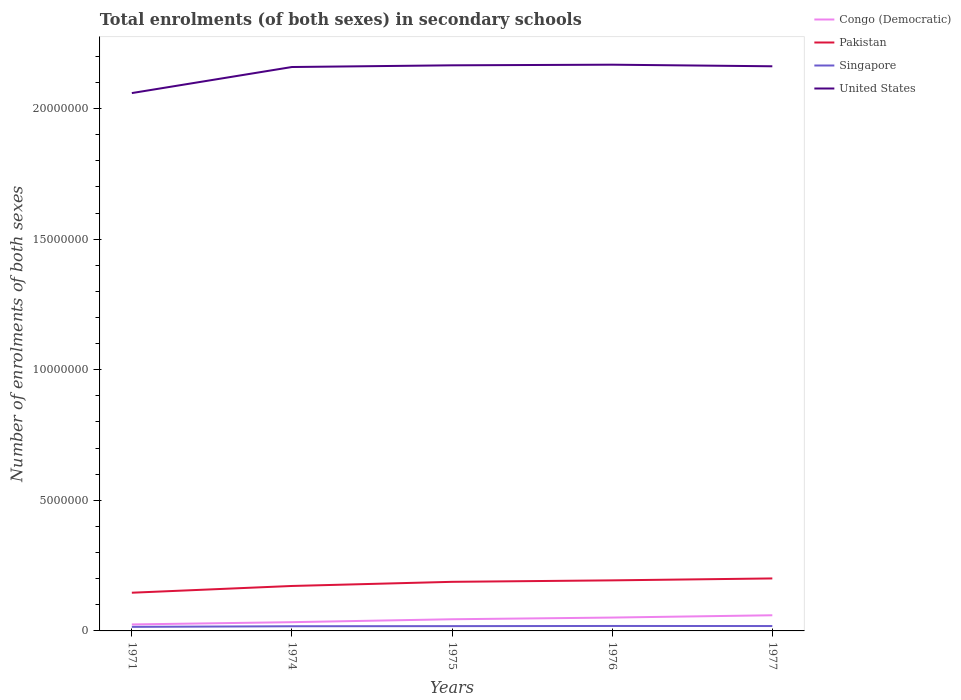Across all years, what is the maximum number of enrolments in secondary schools in Pakistan?
Keep it short and to the point. 1.46e+06. In which year was the number of enrolments in secondary schools in United States maximum?
Make the answer very short. 1971. What is the total number of enrolments in secondary schools in Congo (Democratic) in the graph?
Offer a terse response. -1.98e+05. What is the difference between the highest and the second highest number of enrolments in secondary schools in Pakistan?
Ensure brevity in your answer.  5.47e+05. Is the number of enrolments in secondary schools in Pakistan strictly greater than the number of enrolments in secondary schools in Singapore over the years?
Provide a short and direct response. No. How many lines are there?
Offer a terse response. 4. How many years are there in the graph?
Provide a succinct answer. 5. What is the difference between two consecutive major ticks on the Y-axis?
Give a very brief answer. 5.00e+06. What is the title of the graph?
Provide a short and direct response. Total enrolments (of both sexes) in secondary schools. What is the label or title of the X-axis?
Make the answer very short. Years. What is the label or title of the Y-axis?
Give a very brief answer. Number of enrolments of both sexes. What is the Number of enrolments of both sexes in Congo (Democratic) in 1971?
Provide a short and direct response. 2.48e+05. What is the Number of enrolments of both sexes of Pakistan in 1971?
Give a very brief answer. 1.46e+06. What is the Number of enrolments of both sexes in Singapore in 1971?
Keep it short and to the point. 1.56e+05. What is the Number of enrolments of both sexes in United States in 1971?
Offer a terse response. 2.06e+07. What is the Number of enrolments of both sexes in Congo (Democratic) in 1974?
Your answer should be very brief. 3.35e+05. What is the Number of enrolments of both sexes of Pakistan in 1974?
Provide a short and direct response. 1.72e+06. What is the Number of enrolments of both sexes in Singapore in 1974?
Provide a succinct answer. 1.79e+05. What is the Number of enrolments of both sexes of United States in 1974?
Your answer should be compact. 2.16e+07. What is the Number of enrolments of both sexes of Congo (Democratic) in 1975?
Offer a very short reply. 4.47e+05. What is the Number of enrolments of both sexes in Pakistan in 1975?
Give a very brief answer. 1.88e+06. What is the Number of enrolments of both sexes of Singapore in 1975?
Your answer should be very brief. 1.83e+05. What is the Number of enrolments of both sexes in United States in 1975?
Provide a succinct answer. 2.17e+07. What is the Number of enrolments of both sexes in Congo (Democratic) in 1976?
Give a very brief answer. 5.11e+05. What is the Number of enrolments of both sexes in Pakistan in 1976?
Your answer should be very brief. 1.94e+06. What is the Number of enrolments of both sexes in Singapore in 1976?
Your answer should be compact. 1.90e+05. What is the Number of enrolments of both sexes of United States in 1976?
Provide a succinct answer. 2.17e+07. What is the Number of enrolments of both sexes of Congo (Democratic) in 1977?
Provide a short and direct response. 5.99e+05. What is the Number of enrolments of both sexes in Pakistan in 1977?
Your answer should be very brief. 2.01e+06. What is the Number of enrolments of both sexes of Singapore in 1977?
Keep it short and to the point. 1.87e+05. What is the Number of enrolments of both sexes of United States in 1977?
Offer a very short reply. 2.16e+07. Across all years, what is the maximum Number of enrolments of both sexes of Congo (Democratic)?
Ensure brevity in your answer.  5.99e+05. Across all years, what is the maximum Number of enrolments of both sexes of Pakistan?
Keep it short and to the point. 2.01e+06. Across all years, what is the maximum Number of enrolments of both sexes in Singapore?
Your response must be concise. 1.90e+05. Across all years, what is the maximum Number of enrolments of both sexes of United States?
Your answer should be compact. 2.17e+07. Across all years, what is the minimum Number of enrolments of both sexes of Congo (Democratic)?
Your answer should be compact. 2.48e+05. Across all years, what is the minimum Number of enrolments of both sexes in Pakistan?
Your response must be concise. 1.46e+06. Across all years, what is the minimum Number of enrolments of both sexes in Singapore?
Provide a short and direct response. 1.56e+05. Across all years, what is the minimum Number of enrolments of both sexes of United States?
Your answer should be very brief. 2.06e+07. What is the total Number of enrolments of both sexes in Congo (Democratic) in the graph?
Your answer should be very brief. 2.14e+06. What is the total Number of enrolments of both sexes of Pakistan in the graph?
Offer a very short reply. 9.01e+06. What is the total Number of enrolments of both sexes in Singapore in the graph?
Give a very brief answer. 8.95e+05. What is the total Number of enrolments of both sexes of United States in the graph?
Your answer should be compact. 1.07e+08. What is the difference between the Number of enrolments of both sexes in Congo (Democratic) in 1971 and that in 1974?
Your answer should be compact. -8.69e+04. What is the difference between the Number of enrolments of both sexes of Pakistan in 1971 and that in 1974?
Offer a terse response. -2.59e+05. What is the difference between the Number of enrolments of both sexes in Singapore in 1971 and that in 1974?
Offer a terse response. -2.30e+04. What is the difference between the Number of enrolments of both sexes in United States in 1971 and that in 1974?
Your response must be concise. -9.98e+05. What is the difference between the Number of enrolments of both sexes in Congo (Democratic) in 1971 and that in 1975?
Your answer should be very brief. -1.98e+05. What is the difference between the Number of enrolments of both sexes in Pakistan in 1971 and that in 1975?
Your answer should be very brief. -4.17e+05. What is the difference between the Number of enrolments of both sexes in Singapore in 1971 and that in 1975?
Ensure brevity in your answer.  -2.76e+04. What is the difference between the Number of enrolments of both sexes of United States in 1971 and that in 1975?
Offer a very short reply. -1.06e+06. What is the difference between the Number of enrolments of both sexes of Congo (Democratic) in 1971 and that in 1976?
Offer a terse response. -2.63e+05. What is the difference between the Number of enrolments of both sexes of Pakistan in 1971 and that in 1976?
Your answer should be compact. -4.73e+05. What is the difference between the Number of enrolments of both sexes of Singapore in 1971 and that in 1976?
Make the answer very short. -3.40e+04. What is the difference between the Number of enrolments of both sexes in United States in 1971 and that in 1976?
Give a very brief answer. -1.09e+06. What is the difference between the Number of enrolments of both sexes in Congo (Democratic) in 1971 and that in 1977?
Keep it short and to the point. -3.51e+05. What is the difference between the Number of enrolments of both sexes of Pakistan in 1971 and that in 1977?
Offer a terse response. -5.47e+05. What is the difference between the Number of enrolments of both sexes in Singapore in 1971 and that in 1977?
Offer a very short reply. -3.13e+04. What is the difference between the Number of enrolments of both sexes of United States in 1971 and that in 1977?
Give a very brief answer. -1.03e+06. What is the difference between the Number of enrolments of both sexes in Congo (Democratic) in 1974 and that in 1975?
Keep it short and to the point. -1.11e+05. What is the difference between the Number of enrolments of both sexes of Pakistan in 1974 and that in 1975?
Offer a very short reply. -1.58e+05. What is the difference between the Number of enrolments of both sexes of Singapore in 1974 and that in 1975?
Offer a very short reply. -4691. What is the difference between the Number of enrolments of both sexes in United States in 1974 and that in 1975?
Make the answer very short. -6.50e+04. What is the difference between the Number of enrolments of both sexes of Congo (Democratic) in 1974 and that in 1976?
Provide a short and direct response. -1.76e+05. What is the difference between the Number of enrolments of both sexes in Pakistan in 1974 and that in 1976?
Ensure brevity in your answer.  -2.14e+05. What is the difference between the Number of enrolments of both sexes in Singapore in 1974 and that in 1976?
Your answer should be compact. -1.11e+04. What is the difference between the Number of enrolments of both sexes of United States in 1974 and that in 1976?
Keep it short and to the point. -8.90e+04. What is the difference between the Number of enrolments of both sexes of Congo (Democratic) in 1974 and that in 1977?
Give a very brief answer. -2.64e+05. What is the difference between the Number of enrolments of both sexes in Pakistan in 1974 and that in 1977?
Make the answer very short. -2.88e+05. What is the difference between the Number of enrolments of both sexes of Singapore in 1974 and that in 1977?
Offer a very short reply. -8361. What is the difference between the Number of enrolments of both sexes of United States in 1974 and that in 1977?
Offer a terse response. -2.80e+04. What is the difference between the Number of enrolments of both sexes of Congo (Democratic) in 1975 and that in 1976?
Offer a very short reply. -6.48e+04. What is the difference between the Number of enrolments of both sexes of Pakistan in 1975 and that in 1976?
Your answer should be compact. -5.63e+04. What is the difference between the Number of enrolments of both sexes in Singapore in 1975 and that in 1976?
Your answer should be very brief. -6379. What is the difference between the Number of enrolments of both sexes in United States in 1975 and that in 1976?
Make the answer very short. -2.40e+04. What is the difference between the Number of enrolments of both sexes in Congo (Democratic) in 1975 and that in 1977?
Ensure brevity in your answer.  -1.53e+05. What is the difference between the Number of enrolments of both sexes of Pakistan in 1975 and that in 1977?
Offer a terse response. -1.30e+05. What is the difference between the Number of enrolments of both sexes in Singapore in 1975 and that in 1977?
Your response must be concise. -3670. What is the difference between the Number of enrolments of both sexes in United States in 1975 and that in 1977?
Give a very brief answer. 3.70e+04. What is the difference between the Number of enrolments of both sexes of Congo (Democratic) in 1976 and that in 1977?
Make the answer very short. -8.79e+04. What is the difference between the Number of enrolments of both sexes in Pakistan in 1976 and that in 1977?
Offer a very short reply. -7.36e+04. What is the difference between the Number of enrolments of both sexes in Singapore in 1976 and that in 1977?
Provide a short and direct response. 2709. What is the difference between the Number of enrolments of both sexes in United States in 1976 and that in 1977?
Your response must be concise. 6.10e+04. What is the difference between the Number of enrolments of both sexes of Congo (Democratic) in 1971 and the Number of enrolments of both sexes of Pakistan in 1974?
Your answer should be very brief. -1.47e+06. What is the difference between the Number of enrolments of both sexes of Congo (Democratic) in 1971 and the Number of enrolments of both sexes of Singapore in 1974?
Your answer should be very brief. 6.96e+04. What is the difference between the Number of enrolments of both sexes in Congo (Democratic) in 1971 and the Number of enrolments of both sexes in United States in 1974?
Keep it short and to the point. -2.13e+07. What is the difference between the Number of enrolments of both sexes of Pakistan in 1971 and the Number of enrolments of both sexes of Singapore in 1974?
Give a very brief answer. 1.28e+06. What is the difference between the Number of enrolments of both sexes in Pakistan in 1971 and the Number of enrolments of both sexes in United States in 1974?
Your answer should be very brief. -2.01e+07. What is the difference between the Number of enrolments of both sexes in Singapore in 1971 and the Number of enrolments of both sexes in United States in 1974?
Make the answer very short. -2.14e+07. What is the difference between the Number of enrolments of both sexes in Congo (Democratic) in 1971 and the Number of enrolments of both sexes in Pakistan in 1975?
Ensure brevity in your answer.  -1.63e+06. What is the difference between the Number of enrolments of both sexes in Congo (Democratic) in 1971 and the Number of enrolments of both sexes in Singapore in 1975?
Offer a terse response. 6.50e+04. What is the difference between the Number of enrolments of both sexes of Congo (Democratic) in 1971 and the Number of enrolments of both sexes of United States in 1975?
Offer a very short reply. -2.14e+07. What is the difference between the Number of enrolments of both sexes in Pakistan in 1971 and the Number of enrolments of both sexes in Singapore in 1975?
Make the answer very short. 1.28e+06. What is the difference between the Number of enrolments of both sexes in Pakistan in 1971 and the Number of enrolments of both sexes in United States in 1975?
Provide a short and direct response. -2.02e+07. What is the difference between the Number of enrolments of both sexes of Singapore in 1971 and the Number of enrolments of both sexes of United States in 1975?
Keep it short and to the point. -2.15e+07. What is the difference between the Number of enrolments of both sexes in Congo (Democratic) in 1971 and the Number of enrolments of both sexes in Pakistan in 1976?
Ensure brevity in your answer.  -1.69e+06. What is the difference between the Number of enrolments of both sexes in Congo (Democratic) in 1971 and the Number of enrolments of both sexes in Singapore in 1976?
Your response must be concise. 5.86e+04. What is the difference between the Number of enrolments of both sexes of Congo (Democratic) in 1971 and the Number of enrolments of both sexes of United States in 1976?
Make the answer very short. -2.14e+07. What is the difference between the Number of enrolments of both sexes in Pakistan in 1971 and the Number of enrolments of both sexes in Singapore in 1976?
Your response must be concise. 1.27e+06. What is the difference between the Number of enrolments of both sexes in Pakistan in 1971 and the Number of enrolments of both sexes in United States in 1976?
Give a very brief answer. -2.02e+07. What is the difference between the Number of enrolments of both sexes of Singapore in 1971 and the Number of enrolments of both sexes of United States in 1976?
Your answer should be very brief. -2.15e+07. What is the difference between the Number of enrolments of both sexes of Congo (Democratic) in 1971 and the Number of enrolments of both sexes of Pakistan in 1977?
Your answer should be very brief. -1.76e+06. What is the difference between the Number of enrolments of both sexes in Congo (Democratic) in 1971 and the Number of enrolments of both sexes in Singapore in 1977?
Your response must be concise. 6.13e+04. What is the difference between the Number of enrolments of both sexes of Congo (Democratic) in 1971 and the Number of enrolments of both sexes of United States in 1977?
Your answer should be very brief. -2.14e+07. What is the difference between the Number of enrolments of both sexes in Pakistan in 1971 and the Number of enrolments of both sexes in Singapore in 1977?
Your answer should be compact. 1.28e+06. What is the difference between the Number of enrolments of both sexes in Pakistan in 1971 and the Number of enrolments of both sexes in United States in 1977?
Provide a succinct answer. -2.02e+07. What is the difference between the Number of enrolments of both sexes of Singapore in 1971 and the Number of enrolments of both sexes of United States in 1977?
Your answer should be very brief. -2.15e+07. What is the difference between the Number of enrolments of both sexes of Congo (Democratic) in 1974 and the Number of enrolments of both sexes of Pakistan in 1975?
Offer a very short reply. -1.54e+06. What is the difference between the Number of enrolments of both sexes of Congo (Democratic) in 1974 and the Number of enrolments of both sexes of Singapore in 1975?
Provide a succinct answer. 1.52e+05. What is the difference between the Number of enrolments of both sexes in Congo (Democratic) in 1974 and the Number of enrolments of both sexes in United States in 1975?
Ensure brevity in your answer.  -2.13e+07. What is the difference between the Number of enrolments of both sexes of Pakistan in 1974 and the Number of enrolments of both sexes of Singapore in 1975?
Make the answer very short. 1.54e+06. What is the difference between the Number of enrolments of both sexes in Pakistan in 1974 and the Number of enrolments of both sexes in United States in 1975?
Offer a very short reply. -1.99e+07. What is the difference between the Number of enrolments of both sexes of Singapore in 1974 and the Number of enrolments of both sexes of United States in 1975?
Keep it short and to the point. -2.15e+07. What is the difference between the Number of enrolments of both sexes of Congo (Democratic) in 1974 and the Number of enrolments of both sexes of Pakistan in 1976?
Keep it short and to the point. -1.60e+06. What is the difference between the Number of enrolments of both sexes in Congo (Democratic) in 1974 and the Number of enrolments of both sexes in Singapore in 1976?
Provide a succinct answer. 1.45e+05. What is the difference between the Number of enrolments of both sexes of Congo (Democratic) in 1974 and the Number of enrolments of both sexes of United States in 1976?
Keep it short and to the point. -2.13e+07. What is the difference between the Number of enrolments of both sexes of Pakistan in 1974 and the Number of enrolments of both sexes of Singapore in 1976?
Keep it short and to the point. 1.53e+06. What is the difference between the Number of enrolments of both sexes of Pakistan in 1974 and the Number of enrolments of both sexes of United States in 1976?
Provide a succinct answer. -2.00e+07. What is the difference between the Number of enrolments of both sexes of Singapore in 1974 and the Number of enrolments of both sexes of United States in 1976?
Offer a very short reply. -2.15e+07. What is the difference between the Number of enrolments of both sexes in Congo (Democratic) in 1974 and the Number of enrolments of both sexes in Pakistan in 1977?
Your answer should be very brief. -1.67e+06. What is the difference between the Number of enrolments of both sexes in Congo (Democratic) in 1974 and the Number of enrolments of both sexes in Singapore in 1977?
Offer a very short reply. 1.48e+05. What is the difference between the Number of enrolments of both sexes of Congo (Democratic) in 1974 and the Number of enrolments of both sexes of United States in 1977?
Offer a very short reply. -2.13e+07. What is the difference between the Number of enrolments of both sexes in Pakistan in 1974 and the Number of enrolments of both sexes in Singapore in 1977?
Your response must be concise. 1.53e+06. What is the difference between the Number of enrolments of both sexes in Pakistan in 1974 and the Number of enrolments of both sexes in United States in 1977?
Your answer should be very brief. -1.99e+07. What is the difference between the Number of enrolments of both sexes of Singapore in 1974 and the Number of enrolments of both sexes of United States in 1977?
Keep it short and to the point. -2.14e+07. What is the difference between the Number of enrolments of both sexes in Congo (Democratic) in 1975 and the Number of enrolments of both sexes in Pakistan in 1976?
Your response must be concise. -1.49e+06. What is the difference between the Number of enrolments of both sexes of Congo (Democratic) in 1975 and the Number of enrolments of both sexes of Singapore in 1976?
Make the answer very short. 2.57e+05. What is the difference between the Number of enrolments of both sexes of Congo (Democratic) in 1975 and the Number of enrolments of both sexes of United States in 1976?
Keep it short and to the point. -2.12e+07. What is the difference between the Number of enrolments of both sexes of Pakistan in 1975 and the Number of enrolments of both sexes of Singapore in 1976?
Your answer should be very brief. 1.69e+06. What is the difference between the Number of enrolments of both sexes in Pakistan in 1975 and the Number of enrolments of both sexes in United States in 1976?
Provide a short and direct response. -1.98e+07. What is the difference between the Number of enrolments of both sexes of Singapore in 1975 and the Number of enrolments of both sexes of United States in 1976?
Provide a succinct answer. -2.15e+07. What is the difference between the Number of enrolments of both sexes of Congo (Democratic) in 1975 and the Number of enrolments of both sexes of Pakistan in 1977?
Provide a succinct answer. -1.56e+06. What is the difference between the Number of enrolments of both sexes of Congo (Democratic) in 1975 and the Number of enrolments of both sexes of Singapore in 1977?
Ensure brevity in your answer.  2.60e+05. What is the difference between the Number of enrolments of both sexes of Congo (Democratic) in 1975 and the Number of enrolments of both sexes of United States in 1977?
Your answer should be very brief. -2.12e+07. What is the difference between the Number of enrolments of both sexes of Pakistan in 1975 and the Number of enrolments of both sexes of Singapore in 1977?
Provide a short and direct response. 1.69e+06. What is the difference between the Number of enrolments of both sexes in Pakistan in 1975 and the Number of enrolments of both sexes in United States in 1977?
Your answer should be compact. -1.97e+07. What is the difference between the Number of enrolments of both sexes in Singapore in 1975 and the Number of enrolments of both sexes in United States in 1977?
Provide a short and direct response. -2.14e+07. What is the difference between the Number of enrolments of both sexes in Congo (Democratic) in 1976 and the Number of enrolments of both sexes in Pakistan in 1977?
Give a very brief answer. -1.50e+06. What is the difference between the Number of enrolments of both sexes in Congo (Democratic) in 1976 and the Number of enrolments of both sexes in Singapore in 1977?
Make the answer very short. 3.24e+05. What is the difference between the Number of enrolments of both sexes of Congo (Democratic) in 1976 and the Number of enrolments of both sexes of United States in 1977?
Your response must be concise. -2.11e+07. What is the difference between the Number of enrolments of both sexes in Pakistan in 1976 and the Number of enrolments of both sexes in Singapore in 1977?
Your response must be concise. 1.75e+06. What is the difference between the Number of enrolments of both sexes in Pakistan in 1976 and the Number of enrolments of both sexes in United States in 1977?
Ensure brevity in your answer.  -1.97e+07. What is the difference between the Number of enrolments of both sexes in Singapore in 1976 and the Number of enrolments of both sexes in United States in 1977?
Provide a succinct answer. -2.14e+07. What is the average Number of enrolments of both sexes in Congo (Democratic) per year?
Give a very brief answer. 4.28e+05. What is the average Number of enrolments of both sexes of Pakistan per year?
Give a very brief answer. 1.80e+06. What is the average Number of enrolments of both sexes in Singapore per year?
Give a very brief answer. 1.79e+05. What is the average Number of enrolments of both sexes of United States per year?
Ensure brevity in your answer.  2.14e+07. In the year 1971, what is the difference between the Number of enrolments of both sexes of Congo (Democratic) and Number of enrolments of both sexes of Pakistan?
Keep it short and to the point. -1.21e+06. In the year 1971, what is the difference between the Number of enrolments of both sexes in Congo (Democratic) and Number of enrolments of both sexes in Singapore?
Ensure brevity in your answer.  9.26e+04. In the year 1971, what is the difference between the Number of enrolments of both sexes in Congo (Democratic) and Number of enrolments of both sexes in United States?
Keep it short and to the point. -2.03e+07. In the year 1971, what is the difference between the Number of enrolments of both sexes in Pakistan and Number of enrolments of both sexes in Singapore?
Your answer should be very brief. 1.31e+06. In the year 1971, what is the difference between the Number of enrolments of both sexes of Pakistan and Number of enrolments of both sexes of United States?
Your answer should be very brief. -1.91e+07. In the year 1971, what is the difference between the Number of enrolments of both sexes of Singapore and Number of enrolments of both sexes of United States?
Your answer should be compact. -2.04e+07. In the year 1974, what is the difference between the Number of enrolments of both sexes of Congo (Democratic) and Number of enrolments of both sexes of Pakistan?
Keep it short and to the point. -1.39e+06. In the year 1974, what is the difference between the Number of enrolments of both sexes of Congo (Democratic) and Number of enrolments of both sexes of Singapore?
Keep it short and to the point. 1.57e+05. In the year 1974, what is the difference between the Number of enrolments of both sexes in Congo (Democratic) and Number of enrolments of both sexes in United States?
Make the answer very short. -2.13e+07. In the year 1974, what is the difference between the Number of enrolments of both sexes of Pakistan and Number of enrolments of both sexes of Singapore?
Keep it short and to the point. 1.54e+06. In the year 1974, what is the difference between the Number of enrolments of both sexes in Pakistan and Number of enrolments of both sexes in United States?
Your answer should be compact. -1.99e+07. In the year 1974, what is the difference between the Number of enrolments of both sexes of Singapore and Number of enrolments of both sexes of United States?
Give a very brief answer. -2.14e+07. In the year 1975, what is the difference between the Number of enrolments of both sexes in Congo (Democratic) and Number of enrolments of both sexes in Pakistan?
Ensure brevity in your answer.  -1.43e+06. In the year 1975, what is the difference between the Number of enrolments of both sexes of Congo (Democratic) and Number of enrolments of both sexes of Singapore?
Offer a very short reply. 2.63e+05. In the year 1975, what is the difference between the Number of enrolments of both sexes in Congo (Democratic) and Number of enrolments of both sexes in United States?
Your answer should be very brief. -2.12e+07. In the year 1975, what is the difference between the Number of enrolments of both sexes in Pakistan and Number of enrolments of both sexes in Singapore?
Your answer should be compact. 1.70e+06. In the year 1975, what is the difference between the Number of enrolments of both sexes of Pakistan and Number of enrolments of both sexes of United States?
Give a very brief answer. -1.98e+07. In the year 1975, what is the difference between the Number of enrolments of both sexes of Singapore and Number of enrolments of both sexes of United States?
Your answer should be very brief. -2.15e+07. In the year 1976, what is the difference between the Number of enrolments of both sexes of Congo (Democratic) and Number of enrolments of both sexes of Pakistan?
Ensure brevity in your answer.  -1.42e+06. In the year 1976, what is the difference between the Number of enrolments of both sexes in Congo (Democratic) and Number of enrolments of both sexes in Singapore?
Provide a short and direct response. 3.22e+05. In the year 1976, what is the difference between the Number of enrolments of both sexes in Congo (Democratic) and Number of enrolments of both sexes in United States?
Keep it short and to the point. -2.12e+07. In the year 1976, what is the difference between the Number of enrolments of both sexes of Pakistan and Number of enrolments of both sexes of Singapore?
Your answer should be compact. 1.75e+06. In the year 1976, what is the difference between the Number of enrolments of both sexes of Pakistan and Number of enrolments of both sexes of United States?
Give a very brief answer. -1.97e+07. In the year 1976, what is the difference between the Number of enrolments of both sexes in Singapore and Number of enrolments of both sexes in United States?
Your answer should be very brief. -2.15e+07. In the year 1977, what is the difference between the Number of enrolments of both sexes in Congo (Democratic) and Number of enrolments of both sexes in Pakistan?
Keep it short and to the point. -1.41e+06. In the year 1977, what is the difference between the Number of enrolments of both sexes of Congo (Democratic) and Number of enrolments of both sexes of Singapore?
Your answer should be very brief. 4.12e+05. In the year 1977, what is the difference between the Number of enrolments of both sexes in Congo (Democratic) and Number of enrolments of both sexes in United States?
Provide a succinct answer. -2.10e+07. In the year 1977, what is the difference between the Number of enrolments of both sexes in Pakistan and Number of enrolments of both sexes in Singapore?
Provide a succinct answer. 1.82e+06. In the year 1977, what is the difference between the Number of enrolments of both sexes of Pakistan and Number of enrolments of both sexes of United States?
Provide a short and direct response. -1.96e+07. In the year 1977, what is the difference between the Number of enrolments of both sexes of Singapore and Number of enrolments of both sexes of United States?
Offer a very short reply. -2.14e+07. What is the ratio of the Number of enrolments of both sexes of Congo (Democratic) in 1971 to that in 1974?
Provide a short and direct response. 0.74. What is the ratio of the Number of enrolments of both sexes of Pakistan in 1971 to that in 1974?
Your response must be concise. 0.85. What is the ratio of the Number of enrolments of both sexes of Singapore in 1971 to that in 1974?
Your answer should be compact. 0.87. What is the ratio of the Number of enrolments of both sexes of United States in 1971 to that in 1974?
Keep it short and to the point. 0.95. What is the ratio of the Number of enrolments of both sexes in Congo (Democratic) in 1971 to that in 1975?
Your response must be concise. 0.56. What is the ratio of the Number of enrolments of both sexes in Pakistan in 1971 to that in 1975?
Keep it short and to the point. 0.78. What is the ratio of the Number of enrolments of both sexes of Singapore in 1971 to that in 1975?
Keep it short and to the point. 0.85. What is the ratio of the Number of enrolments of both sexes in United States in 1971 to that in 1975?
Make the answer very short. 0.95. What is the ratio of the Number of enrolments of both sexes of Congo (Democratic) in 1971 to that in 1976?
Ensure brevity in your answer.  0.49. What is the ratio of the Number of enrolments of both sexes in Pakistan in 1971 to that in 1976?
Ensure brevity in your answer.  0.76. What is the ratio of the Number of enrolments of both sexes in Singapore in 1971 to that in 1976?
Keep it short and to the point. 0.82. What is the ratio of the Number of enrolments of both sexes in United States in 1971 to that in 1976?
Offer a terse response. 0.95. What is the ratio of the Number of enrolments of both sexes of Congo (Democratic) in 1971 to that in 1977?
Make the answer very short. 0.41. What is the ratio of the Number of enrolments of both sexes in Pakistan in 1971 to that in 1977?
Give a very brief answer. 0.73. What is the ratio of the Number of enrolments of both sexes in Singapore in 1971 to that in 1977?
Your answer should be very brief. 0.83. What is the ratio of the Number of enrolments of both sexes of United States in 1971 to that in 1977?
Keep it short and to the point. 0.95. What is the ratio of the Number of enrolments of both sexes in Congo (Democratic) in 1974 to that in 1975?
Your answer should be compact. 0.75. What is the ratio of the Number of enrolments of both sexes in Pakistan in 1974 to that in 1975?
Offer a terse response. 0.92. What is the ratio of the Number of enrolments of both sexes in Singapore in 1974 to that in 1975?
Give a very brief answer. 0.97. What is the ratio of the Number of enrolments of both sexes in United States in 1974 to that in 1975?
Keep it short and to the point. 1. What is the ratio of the Number of enrolments of both sexes in Congo (Democratic) in 1974 to that in 1976?
Provide a short and direct response. 0.66. What is the ratio of the Number of enrolments of both sexes of Pakistan in 1974 to that in 1976?
Provide a short and direct response. 0.89. What is the ratio of the Number of enrolments of both sexes in Singapore in 1974 to that in 1976?
Give a very brief answer. 0.94. What is the ratio of the Number of enrolments of both sexes of Congo (Democratic) in 1974 to that in 1977?
Your answer should be very brief. 0.56. What is the ratio of the Number of enrolments of both sexes of Pakistan in 1974 to that in 1977?
Offer a terse response. 0.86. What is the ratio of the Number of enrolments of both sexes in Singapore in 1974 to that in 1977?
Offer a very short reply. 0.96. What is the ratio of the Number of enrolments of both sexes of United States in 1974 to that in 1977?
Provide a short and direct response. 1. What is the ratio of the Number of enrolments of both sexes in Congo (Democratic) in 1975 to that in 1976?
Your answer should be very brief. 0.87. What is the ratio of the Number of enrolments of both sexes in Pakistan in 1975 to that in 1976?
Give a very brief answer. 0.97. What is the ratio of the Number of enrolments of both sexes in Singapore in 1975 to that in 1976?
Provide a short and direct response. 0.97. What is the ratio of the Number of enrolments of both sexes in Congo (Democratic) in 1975 to that in 1977?
Your answer should be compact. 0.75. What is the ratio of the Number of enrolments of both sexes in Pakistan in 1975 to that in 1977?
Your response must be concise. 0.94. What is the ratio of the Number of enrolments of both sexes of Singapore in 1975 to that in 1977?
Provide a short and direct response. 0.98. What is the ratio of the Number of enrolments of both sexes in United States in 1975 to that in 1977?
Your response must be concise. 1. What is the ratio of the Number of enrolments of both sexes in Congo (Democratic) in 1976 to that in 1977?
Offer a terse response. 0.85. What is the ratio of the Number of enrolments of both sexes of Pakistan in 1976 to that in 1977?
Make the answer very short. 0.96. What is the ratio of the Number of enrolments of both sexes in Singapore in 1976 to that in 1977?
Give a very brief answer. 1.01. What is the ratio of the Number of enrolments of both sexes in United States in 1976 to that in 1977?
Your answer should be very brief. 1. What is the difference between the highest and the second highest Number of enrolments of both sexes of Congo (Democratic)?
Ensure brevity in your answer.  8.79e+04. What is the difference between the highest and the second highest Number of enrolments of both sexes in Pakistan?
Ensure brevity in your answer.  7.36e+04. What is the difference between the highest and the second highest Number of enrolments of both sexes of Singapore?
Offer a terse response. 2709. What is the difference between the highest and the second highest Number of enrolments of both sexes of United States?
Make the answer very short. 2.40e+04. What is the difference between the highest and the lowest Number of enrolments of both sexes in Congo (Democratic)?
Keep it short and to the point. 3.51e+05. What is the difference between the highest and the lowest Number of enrolments of both sexes in Pakistan?
Keep it short and to the point. 5.47e+05. What is the difference between the highest and the lowest Number of enrolments of both sexes of Singapore?
Provide a succinct answer. 3.40e+04. What is the difference between the highest and the lowest Number of enrolments of both sexes in United States?
Keep it short and to the point. 1.09e+06. 